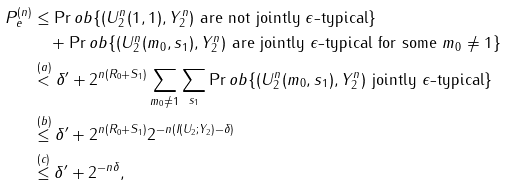Convert formula to latex. <formula><loc_0><loc_0><loc_500><loc_500>P _ { e } ^ { ( n ) } & \leq \Pr o b \{ ( U _ { 2 } ^ { n } ( 1 , 1 ) , Y _ { 2 } ^ { n } ) \text { are not jointly $\epsilon$-typical} \} \\ & \quad + \Pr o b \{ ( U _ { 2 } ^ { n } ( m _ { 0 } , s _ { 1 } ) , Y _ { 2 } ^ { n } ) \text { are jointly $\epsilon$-typical for some } m _ { 0 } \neq 1 \} \\ & \stackrel { ( a ) } { < } \delta ^ { \prime } + 2 ^ { n ( R _ { 0 } + S _ { 1 } ) } \sum _ { m _ { 0 } \neq 1 } \sum _ { s _ { 1 } } \Pr o b \{ ( U _ { 2 } ^ { n } ( m _ { 0 } , s _ { 1 } ) , Y _ { 2 } ^ { n } ) \text { jointly $\epsilon$-typical} \} \\ & \stackrel { ( b ) } { \leq } \delta ^ { \prime } + 2 ^ { n ( R _ { 0 } + S _ { 1 } ) } 2 ^ { - n ( I ( U _ { 2 } ; Y _ { 2 } ) - \delta ) } \\ & \stackrel { ( c ) } { \leq } \delta ^ { \prime } + 2 ^ { - n \delta } ,</formula> 